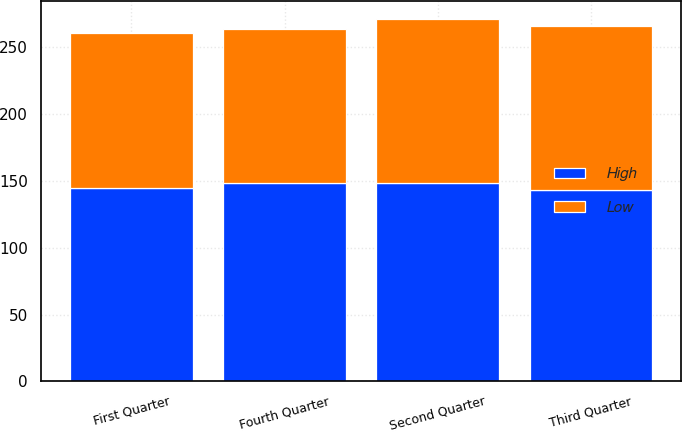<chart> <loc_0><loc_0><loc_500><loc_500><stacked_bar_chart><ecel><fcel>First Quarter<fcel>Second Quarter<fcel>Third Quarter<fcel>Fourth Quarter<nl><fcel>High<fcel>144.69<fcel>148<fcel>143.18<fcel>148.26<nl><fcel>Low<fcel>115.63<fcel>122.91<fcel>122.52<fcel>114.85<nl></chart> 